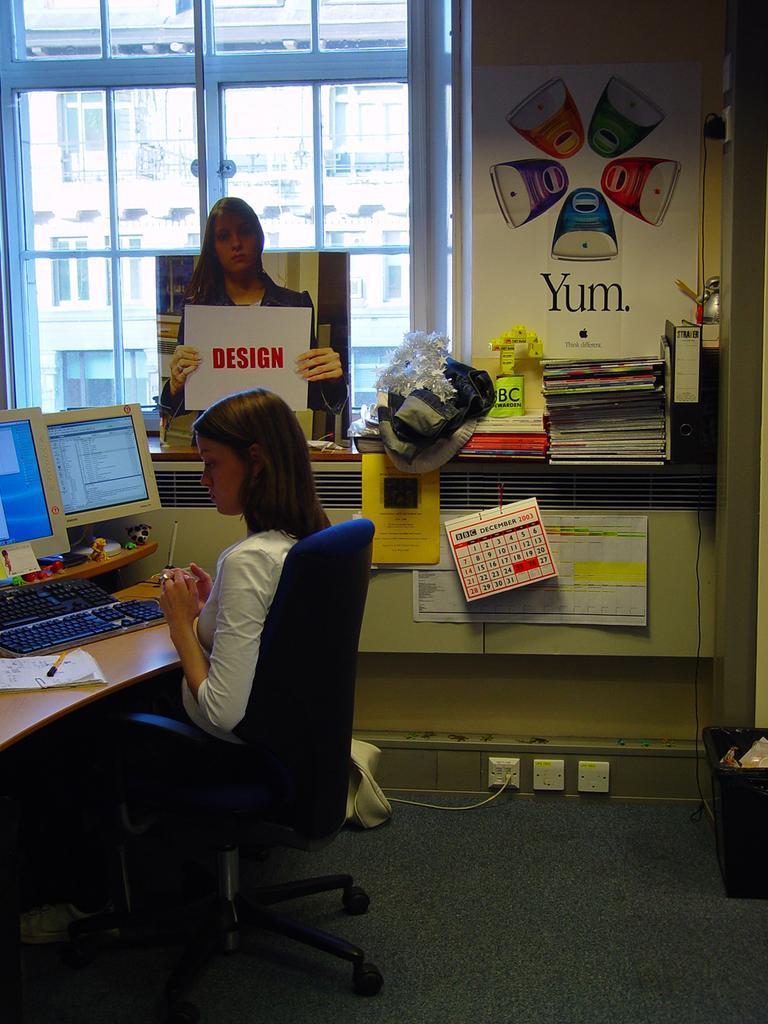Could you give a brief overview of what you see in this image? In this picture a lady is sitting on a desk where monitors on top of it. In the background we observe many posters and labels attached to the wall. There is also a glass window in the background. 